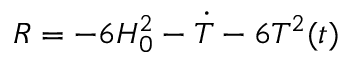<formula> <loc_0><loc_0><loc_500><loc_500>R = - 6 H _ { 0 } ^ { 2 } - \dot { T } - 6 T ^ { 2 } ( t )</formula> 